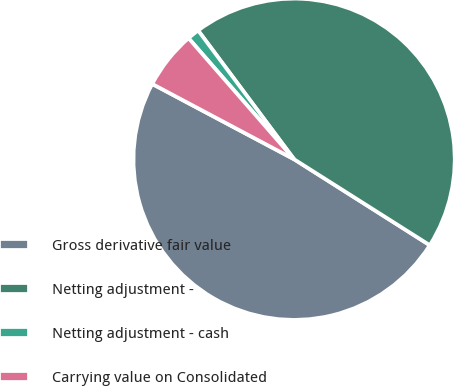Convert chart. <chart><loc_0><loc_0><loc_500><loc_500><pie_chart><fcel>Gross derivative fair value<fcel>Netting adjustment -<fcel>Netting adjustment - cash<fcel>Carrying value on Consolidated<nl><fcel>48.78%<fcel>44.18%<fcel>1.22%<fcel>5.82%<nl></chart> 